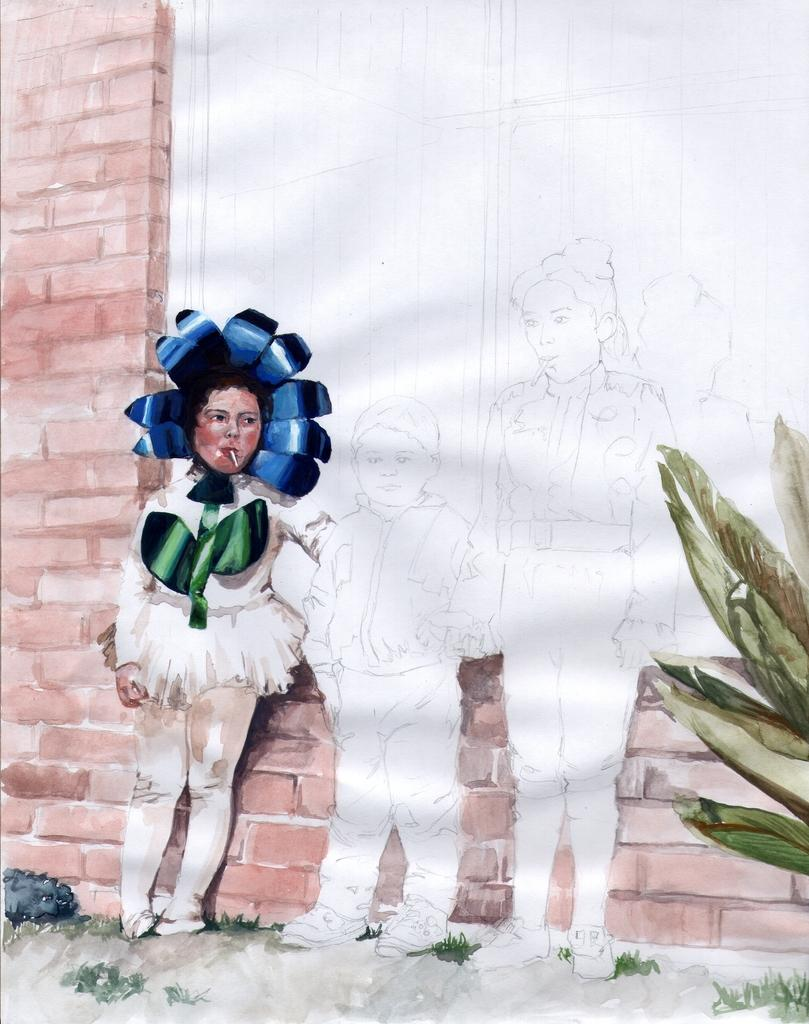What is depicted on the painted wall in the image? The painted wall contains a depiction of people and a plant. Are there any architectural features depicted on the painted wall? Yes, there is a window depicted on the painted wall. What is visible through the window in the painted wall? The window leads to a brick wall. What time is displayed on the clock in the image? There is no clock present in the image; it features a painted wall with a depiction of people, a plant, a window, and a brick wall. Can you see a river flowing through the image? There is no river visible in the image; it features a painted wall with a depiction of people, a plant, a window, and a brick wall. 